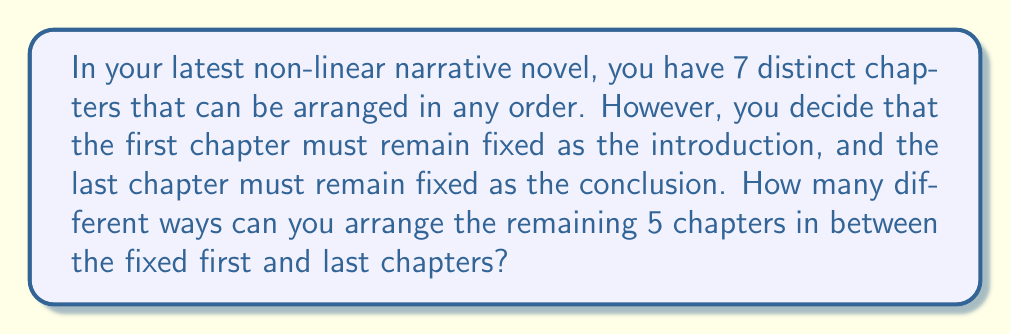Can you solve this math problem? Let's approach this step-by-step:

1) We have 7 total chapters, but the first and last are fixed. This leaves 5 chapters to be arranged.

2) This is a straightforward permutation problem. We need to calculate how many ways we can arrange 5 distinct objects.

3) The formula for permutations of n distinct objects is:

   $$P(n) = n!$$

   Where $n!$ represents the factorial of $n$.

4) In this case, $n = 5$, so we need to calculate:

   $$P(5) = 5!$$

5) Let's expand this:

   $$5! = 5 \times 4 \times 3 \times 2 \times 1 = 120$$

Therefore, there are 120 different ways to arrange the 5 middle chapters between the fixed first and last chapters.
Answer: 120 